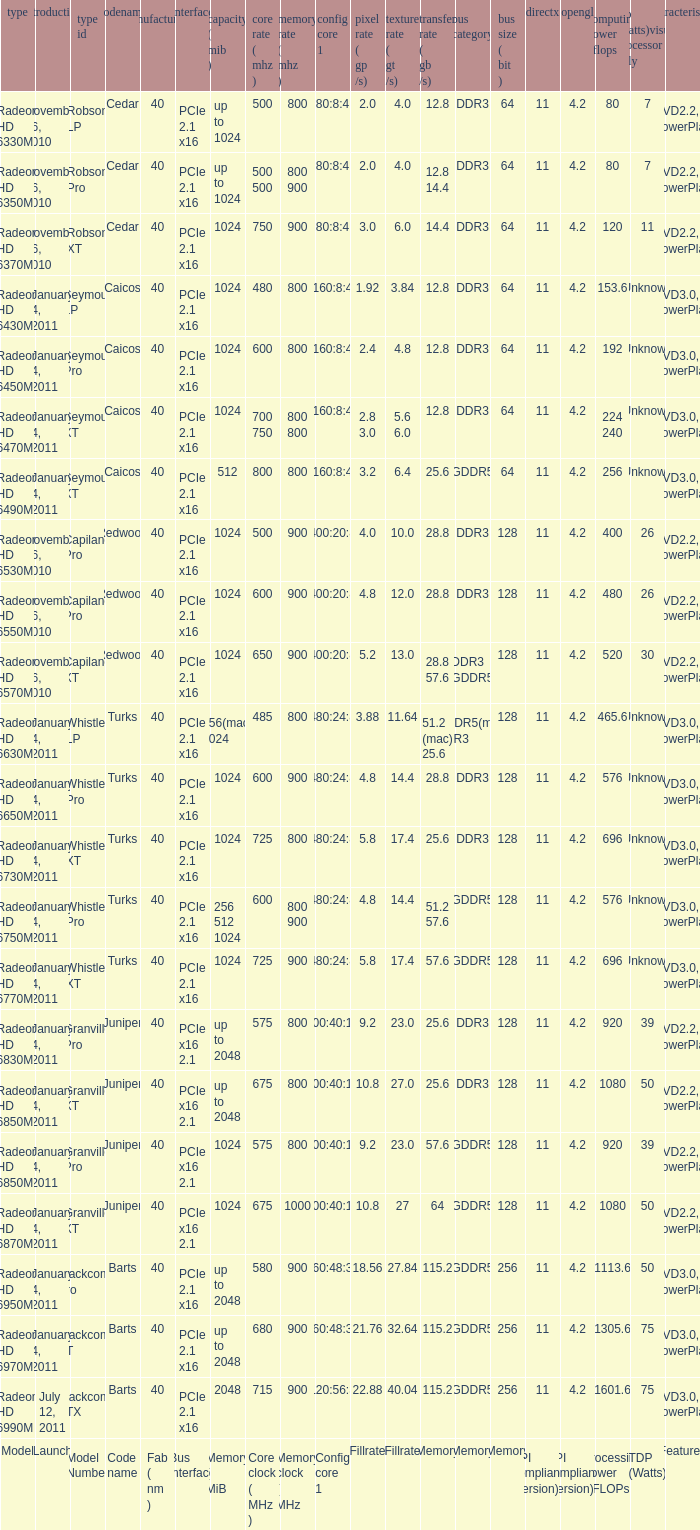If the codename is redwood and the core clock is set to 500 mhz, what is the value for congi core 1? 400:20:8. 